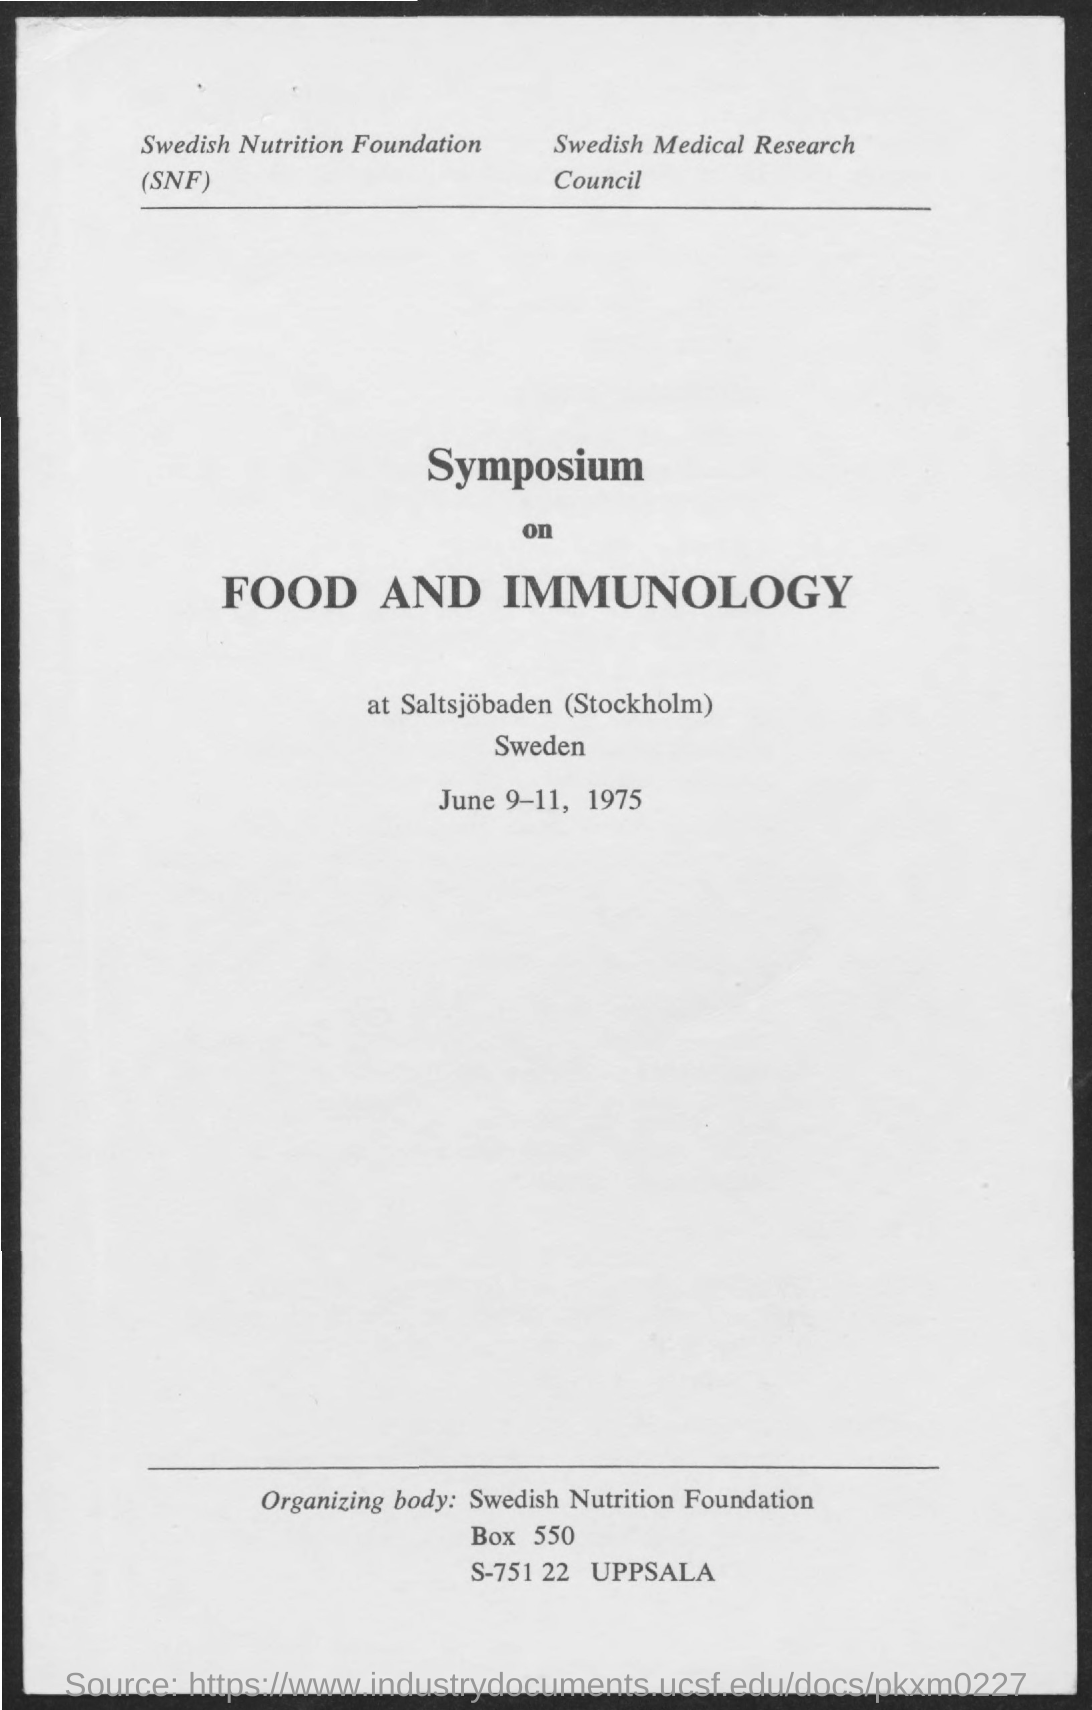What is the name of the council mentioned ?
Provide a succinct answer. Swedish medical research council. What is the full form of snf ?
Offer a terse response. Swedish nutrition foundation. What is the date mentioned in the given page ?
Provide a short and direct response. June 9-11 , 1975. What does the given symposium based on ?
Your answer should be very brief. Food and immunology. 